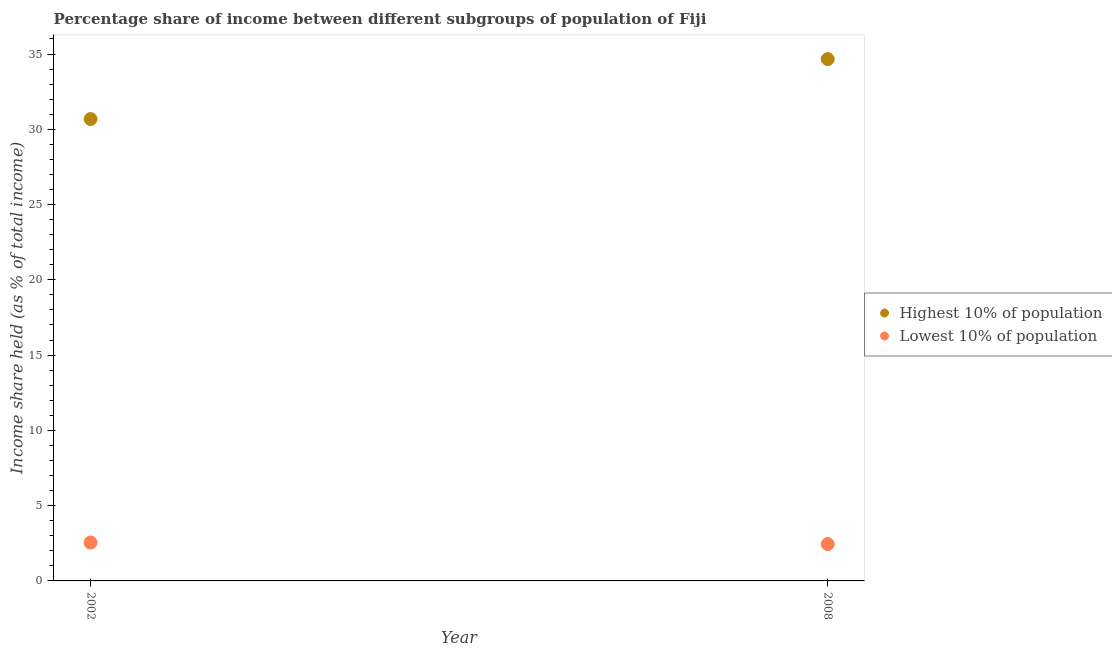How many different coloured dotlines are there?
Offer a very short reply. 2. Is the number of dotlines equal to the number of legend labels?
Keep it short and to the point. Yes. What is the income share held by lowest 10% of the population in 2002?
Give a very brief answer. 2.55. Across all years, what is the maximum income share held by highest 10% of the population?
Give a very brief answer. 34.66. Across all years, what is the minimum income share held by lowest 10% of the population?
Provide a short and direct response. 2.45. In which year was the income share held by lowest 10% of the population minimum?
Your response must be concise. 2008. What is the total income share held by highest 10% of the population in the graph?
Give a very brief answer. 65.34. What is the difference between the income share held by lowest 10% of the population in 2002 and that in 2008?
Make the answer very short. 0.1. What is the difference between the income share held by highest 10% of the population in 2002 and the income share held by lowest 10% of the population in 2008?
Offer a very short reply. 28.23. What is the average income share held by lowest 10% of the population per year?
Offer a very short reply. 2.5. In the year 2002, what is the difference between the income share held by lowest 10% of the population and income share held by highest 10% of the population?
Your answer should be compact. -28.13. What is the ratio of the income share held by highest 10% of the population in 2002 to that in 2008?
Make the answer very short. 0.89. Is the income share held by highest 10% of the population strictly greater than the income share held by lowest 10% of the population over the years?
Provide a succinct answer. Yes. Is the income share held by lowest 10% of the population strictly less than the income share held by highest 10% of the population over the years?
Offer a very short reply. Yes. Are the values on the major ticks of Y-axis written in scientific E-notation?
Give a very brief answer. No. How many legend labels are there?
Your answer should be compact. 2. How are the legend labels stacked?
Your answer should be very brief. Vertical. What is the title of the graph?
Provide a short and direct response. Percentage share of income between different subgroups of population of Fiji. Does "Forest land" appear as one of the legend labels in the graph?
Your answer should be very brief. No. What is the label or title of the X-axis?
Make the answer very short. Year. What is the label or title of the Y-axis?
Your answer should be compact. Income share held (as % of total income). What is the Income share held (as % of total income) of Highest 10% of population in 2002?
Your answer should be very brief. 30.68. What is the Income share held (as % of total income) in Lowest 10% of population in 2002?
Provide a short and direct response. 2.55. What is the Income share held (as % of total income) in Highest 10% of population in 2008?
Provide a succinct answer. 34.66. What is the Income share held (as % of total income) of Lowest 10% of population in 2008?
Offer a terse response. 2.45. Across all years, what is the maximum Income share held (as % of total income) in Highest 10% of population?
Provide a succinct answer. 34.66. Across all years, what is the maximum Income share held (as % of total income) in Lowest 10% of population?
Keep it short and to the point. 2.55. Across all years, what is the minimum Income share held (as % of total income) in Highest 10% of population?
Your response must be concise. 30.68. Across all years, what is the minimum Income share held (as % of total income) in Lowest 10% of population?
Ensure brevity in your answer.  2.45. What is the total Income share held (as % of total income) of Highest 10% of population in the graph?
Your response must be concise. 65.34. What is the total Income share held (as % of total income) of Lowest 10% of population in the graph?
Your response must be concise. 5. What is the difference between the Income share held (as % of total income) of Highest 10% of population in 2002 and that in 2008?
Keep it short and to the point. -3.98. What is the difference between the Income share held (as % of total income) in Lowest 10% of population in 2002 and that in 2008?
Provide a succinct answer. 0.1. What is the difference between the Income share held (as % of total income) in Highest 10% of population in 2002 and the Income share held (as % of total income) in Lowest 10% of population in 2008?
Your response must be concise. 28.23. What is the average Income share held (as % of total income) of Highest 10% of population per year?
Offer a very short reply. 32.67. In the year 2002, what is the difference between the Income share held (as % of total income) of Highest 10% of population and Income share held (as % of total income) of Lowest 10% of population?
Your answer should be compact. 28.13. In the year 2008, what is the difference between the Income share held (as % of total income) in Highest 10% of population and Income share held (as % of total income) in Lowest 10% of population?
Ensure brevity in your answer.  32.21. What is the ratio of the Income share held (as % of total income) of Highest 10% of population in 2002 to that in 2008?
Provide a short and direct response. 0.89. What is the ratio of the Income share held (as % of total income) in Lowest 10% of population in 2002 to that in 2008?
Your answer should be compact. 1.04. What is the difference between the highest and the second highest Income share held (as % of total income) of Highest 10% of population?
Keep it short and to the point. 3.98. What is the difference between the highest and the second highest Income share held (as % of total income) in Lowest 10% of population?
Offer a very short reply. 0.1. What is the difference between the highest and the lowest Income share held (as % of total income) of Highest 10% of population?
Offer a very short reply. 3.98. What is the difference between the highest and the lowest Income share held (as % of total income) of Lowest 10% of population?
Offer a very short reply. 0.1. 